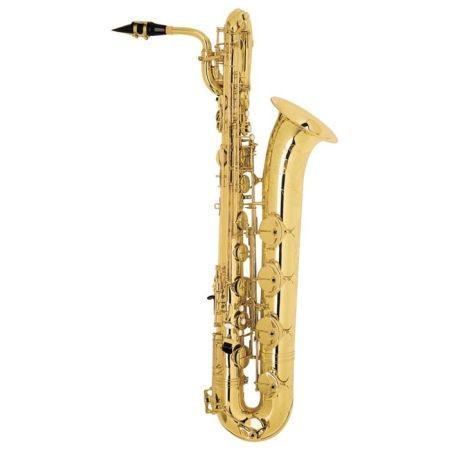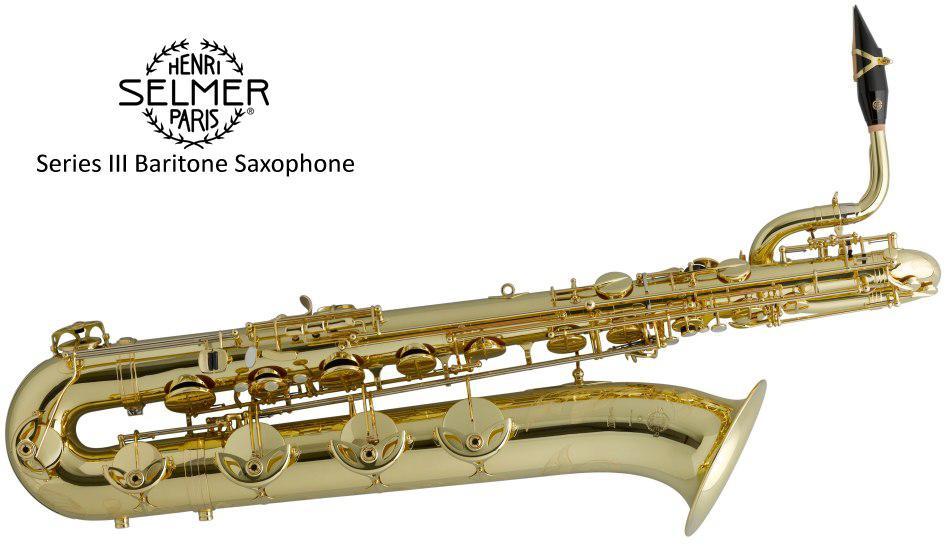The first image is the image on the left, the second image is the image on the right. Examine the images to the left and right. Is the description "Each image shows one upright gold colored saxophone with its bell facing rightward and its mouthpiece facing leftward, and at least one of the saxophones pictured has a loop shape at the top." accurate? Answer yes or no. No. The first image is the image on the left, the second image is the image on the right. Considering the images on both sides, is "There is exactly one black mouthpiece." valid? Answer yes or no. No. 